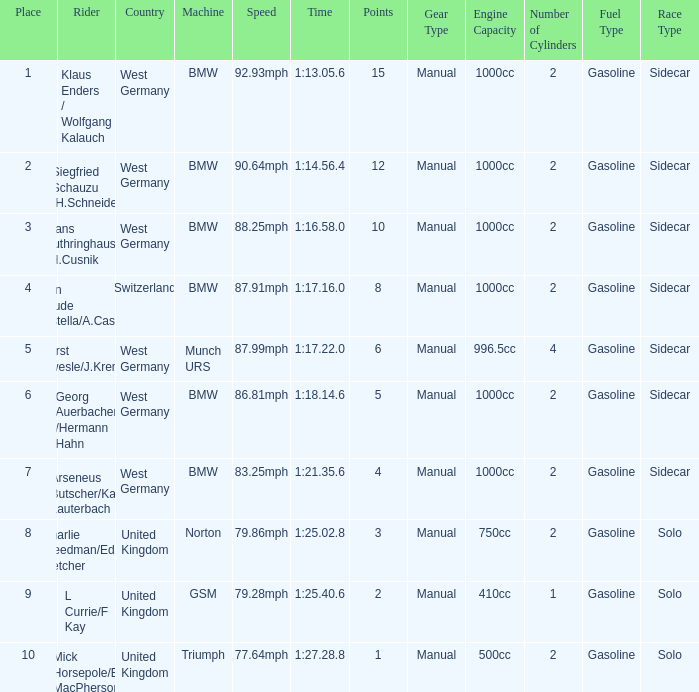Which places have points larger than 10? None. 